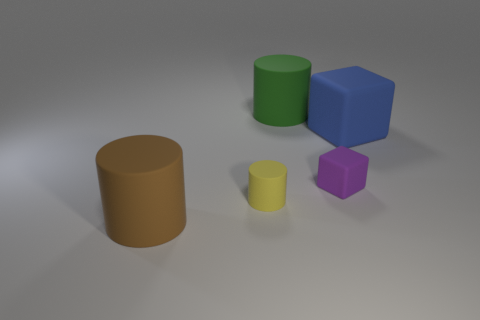Which of these objects is the largest and what could it represent? The largest object appears to be the blue cube. Its size and shape could represent a variety of things depending on context, such as a child's building block, a simplified model of a larger structure, or an educational tool for learning about geometry and spatial relations. 